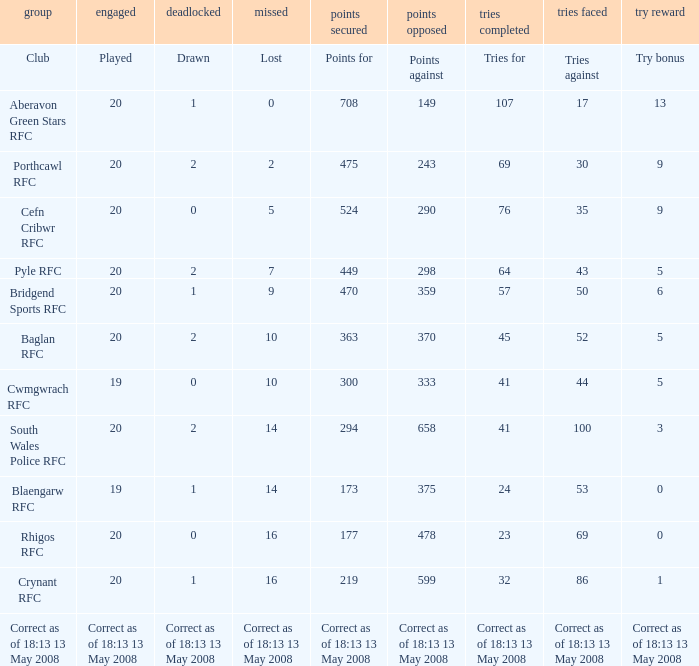What is the tries against when the points are 475? 30.0. 